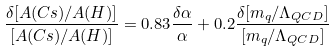<formula> <loc_0><loc_0><loc_500><loc_500>\frac { \delta [ A ( C s ) / A ( H ) ] } { [ A ( C s ) / A ( H ) ] } = 0 . 8 3 \frac { \delta \alpha } { \alpha } + 0 . 2 \frac { \delta [ m _ { q } / \Lambda _ { Q C D } ] } { [ m _ { q } / \Lambda _ { Q C D } ] }</formula> 